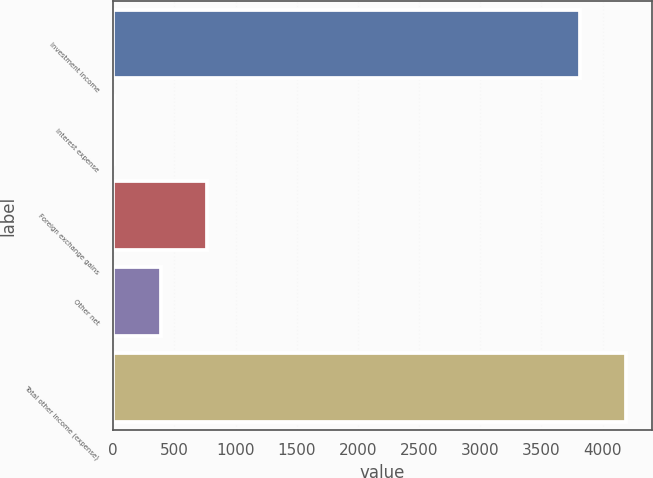<chart> <loc_0><loc_0><loc_500><loc_500><bar_chart><fcel>Investment income<fcel>Interest expense<fcel>Foreign exchange gains<fcel>Other net<fcel>Total other income (expense)<nl><fcel>3814<fcel>8<fcel>770.2<fcel>389.1<fcel>4195.1<nl></chart> 